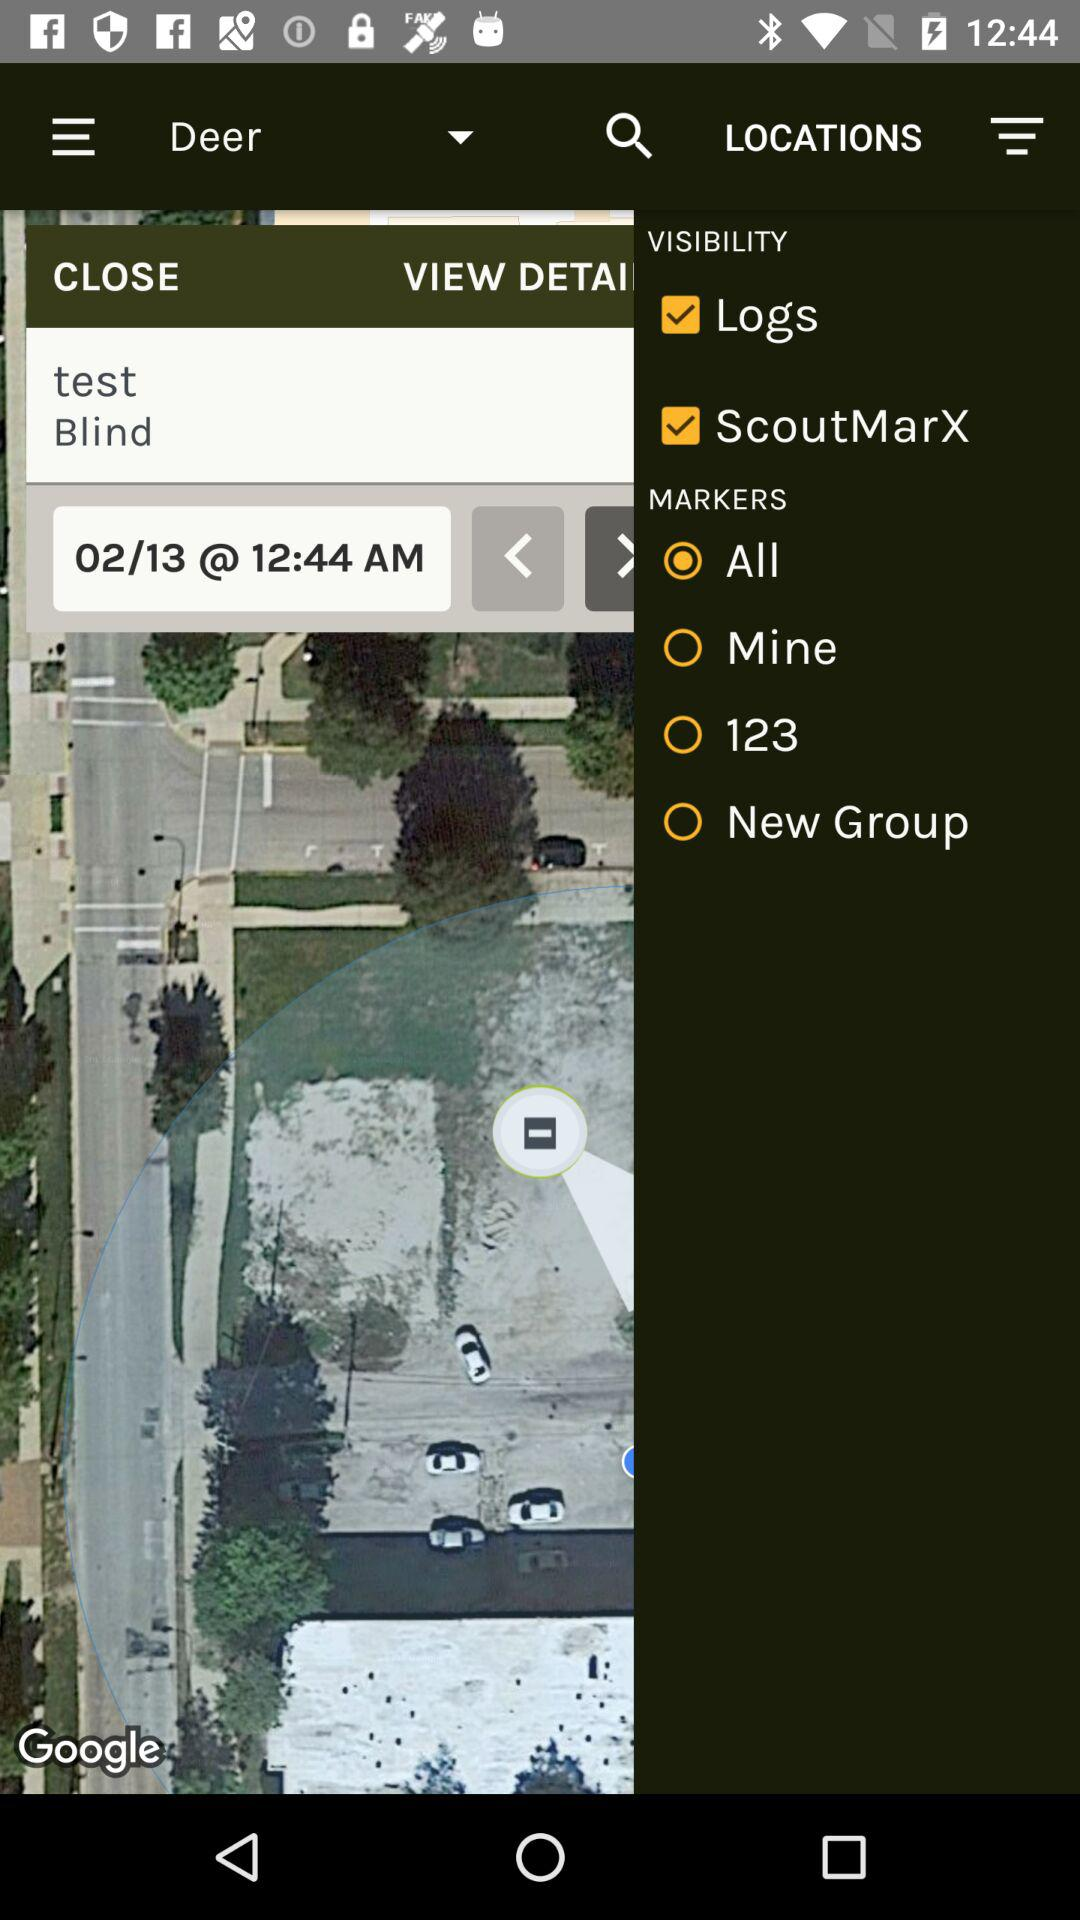Which option is selected for "MARKERS"? The selected option for "MARKERS" is "All". 